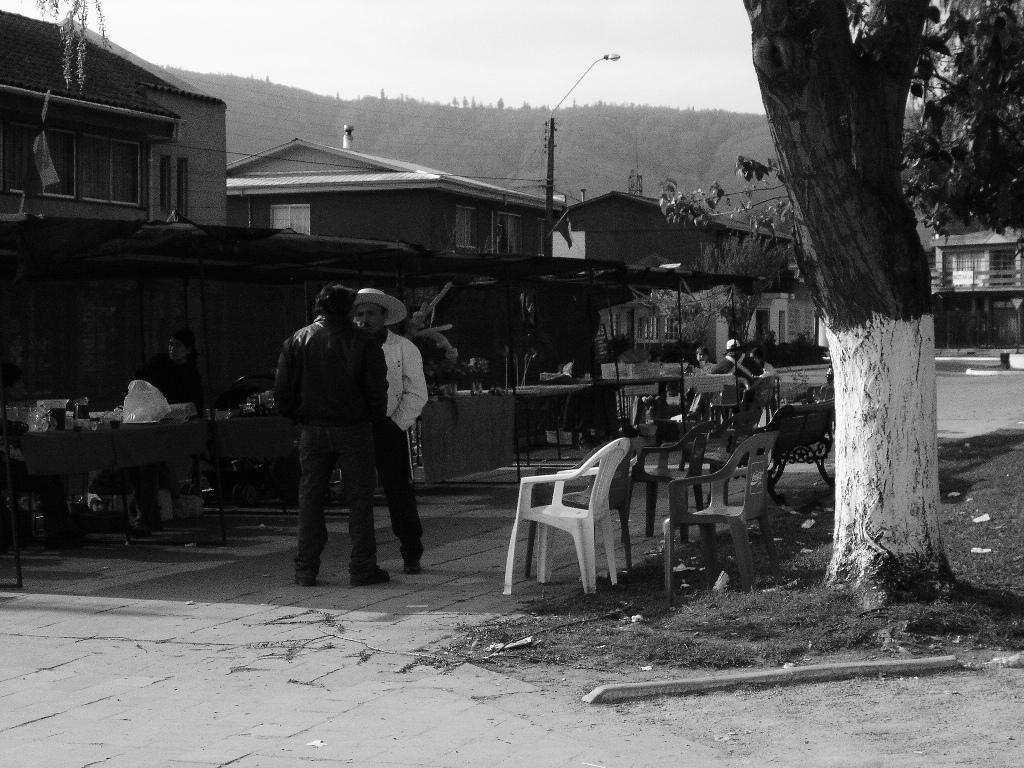How many men are present in the image? There are 2 men standing in the image. What can be seen in the background of the image? There are buildings, trees, tables, chairs, and people in the background of the image. What type of crow is sitting on the wheel in the image? There is no crow or wheel present in the image. How does the wind blow the men's hair in the image? The image does not show the men's hair being blown by the wind; their hair is not visible. 